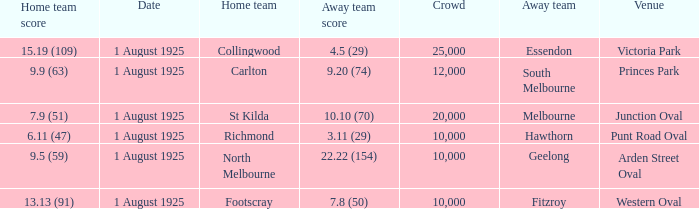At the match where the away team scored 4.5 (29), what was the crowd size? 1.0. 